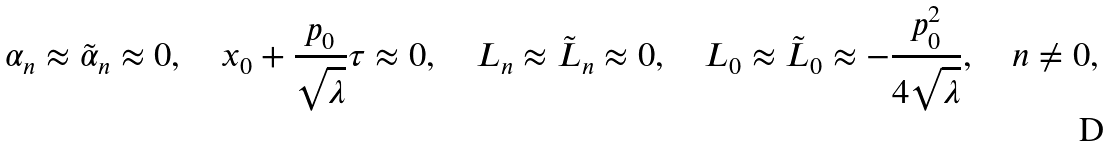<formula> <loc_0><loc_0><loc_500><loc_500>\alpha _ { n } \approx \tilde { \alpha } _ { n } \approx 0 , \quad x _ { 0 } + \frac { p _ { 0 } } { \sqrt { \lambda } } \tau \approx 0 , \quad L _ { n } \approx \tilde { L } _ { n } \approx 0 , \quad L _ { 0 } \approx \tilde { L } _ { 0 } \approx - \frac { p ^ { 2 } _ { 0 } } { 4 \sqrt { \lambda } } , \quad n \neq 0 ,</formula> 